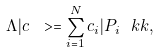Convert formula to latex. <formula><loc_0><loc_0><loc_500><loc_500>\Lambda | c \ > = \sum _ { i = 1 } ^ { N } c _ { i } | P _ { i } \ k k ,</formula> 